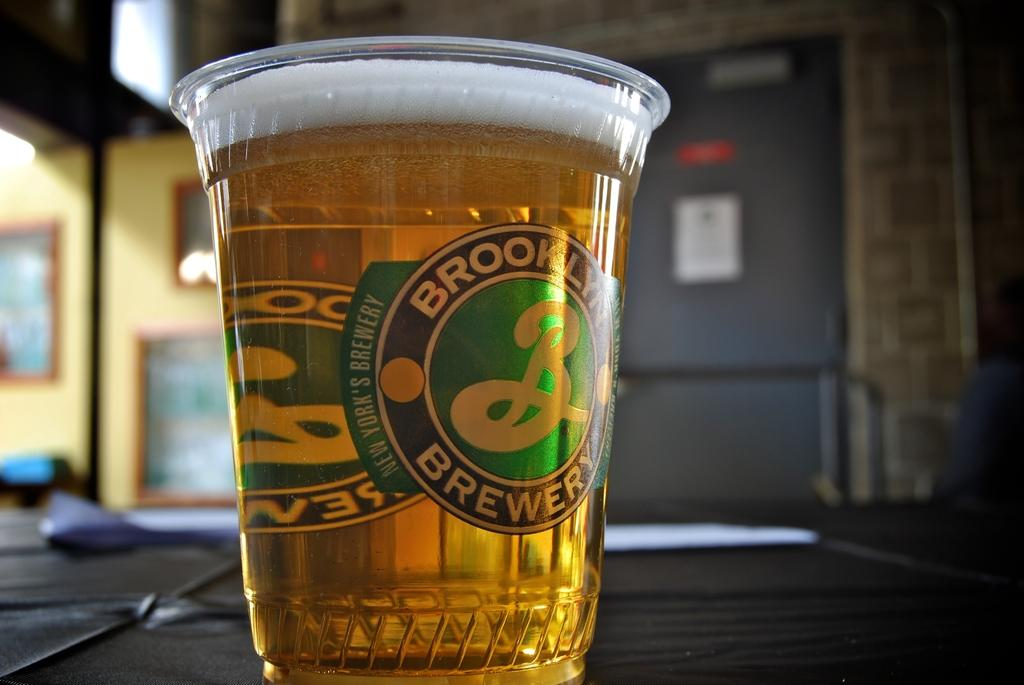<image>
Render a clear and concise summary of the photo. a full cup of beer from brooklyn brewery 